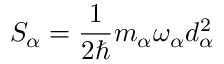Convert formula to latex. <formula><loc_0><loc_0><loc_500><loc_500>S _ { \alpha } = \frac { 1 } { 2 } m _ { \alpha } \omega _ { \alpha } d _ { \alpha } ^ { 2 }</formula> 